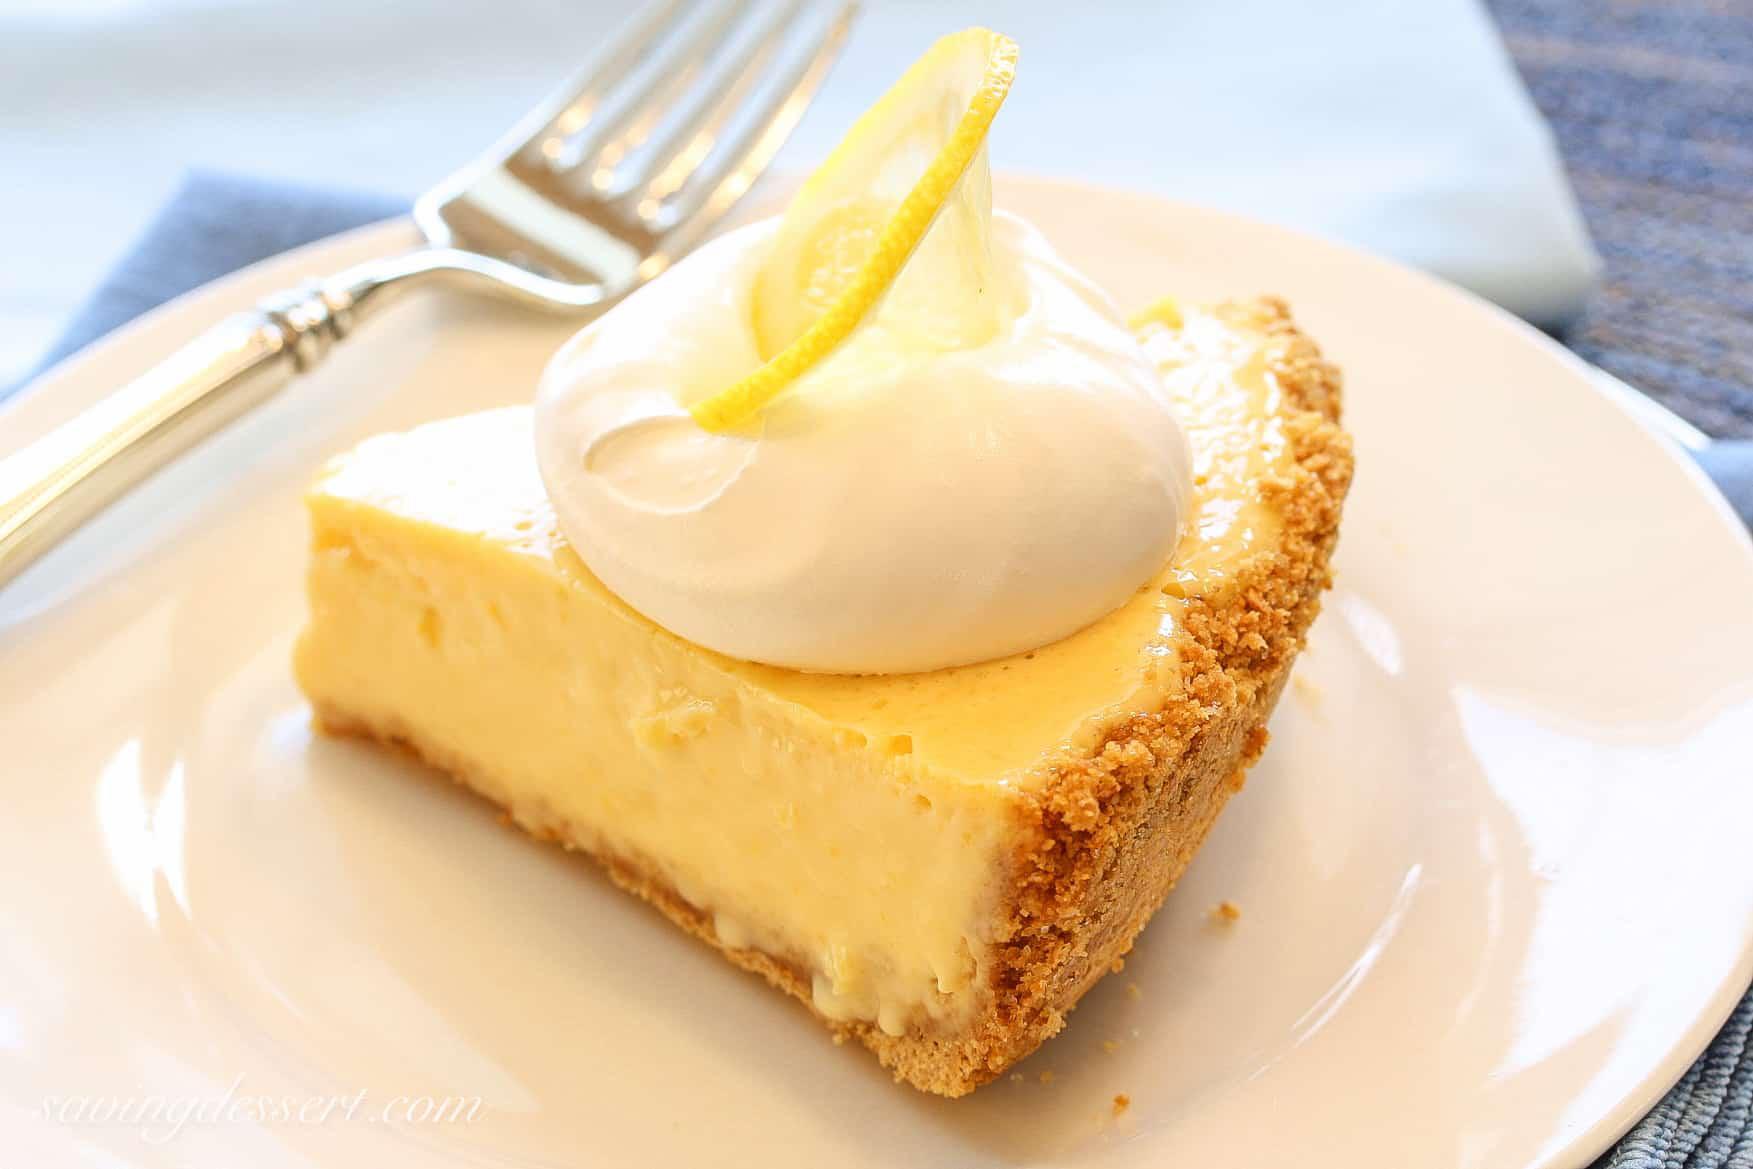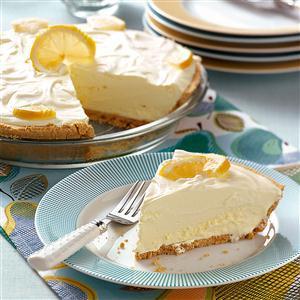The first image is the image on the left, the second image is the image on the right. Given the left and right images, does the statement "The left image shows one pie slice on a white plate, and the right image shows a pie with a slice missing and includes an individual slice." hold true? Answer yes or no. Yes. The first image is the image on the left, the second image is the image on the right. Given the left and right images, does the statement "There is one whole pie." hold true? Answer yes or no. No. 